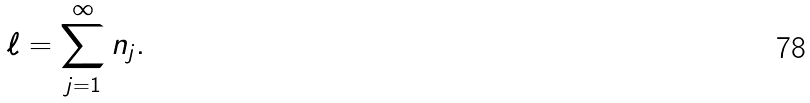Convert formula to latex. <formula><loc_0><loc_0><loc_500><loc_500>\ell = \sum _ { j = 1 } ^ { \infty } n _ { j } .</formula> 